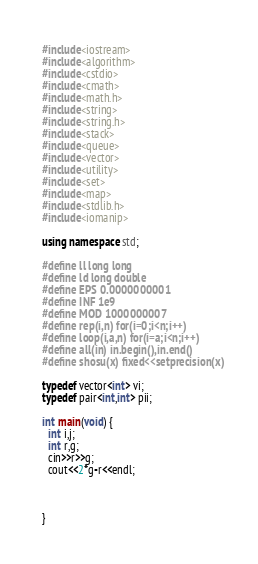Convert code to text. <code><loc_0><loc_0><loc_500><loc_500><_C++_>#include<iostream>
#include<algorithm>
#include<cstdio>
#include<cmath>
#include<math.h>
#include<string>
#include<string.h>
#include<stack>
#include<queue>
#include<vector>
#include<utility>
#include<set>
#include<map>
#include<stdlib.h>
#include<iomanip>

using namespace std;

#define ll long long
#define ld long double
#define EPS 0.0000000001
#define INF 1e9
#define MOD 1000000007
#define rep(i,n) for(i=0;i<n;i++)
#define loop(i,a,n) for(i=a;i<n;i++)
#define all(in) in.begin(),in.end()
#define shosu(x) fixed<<setprecision(x)

typedef vector<int> vi;
typedef pair<int,int> pii;

int main(void) {
  int i,j;
  int r,g;
  cin>>r>>g;
  cout<<2*g-r<<endl;



}
</code> 